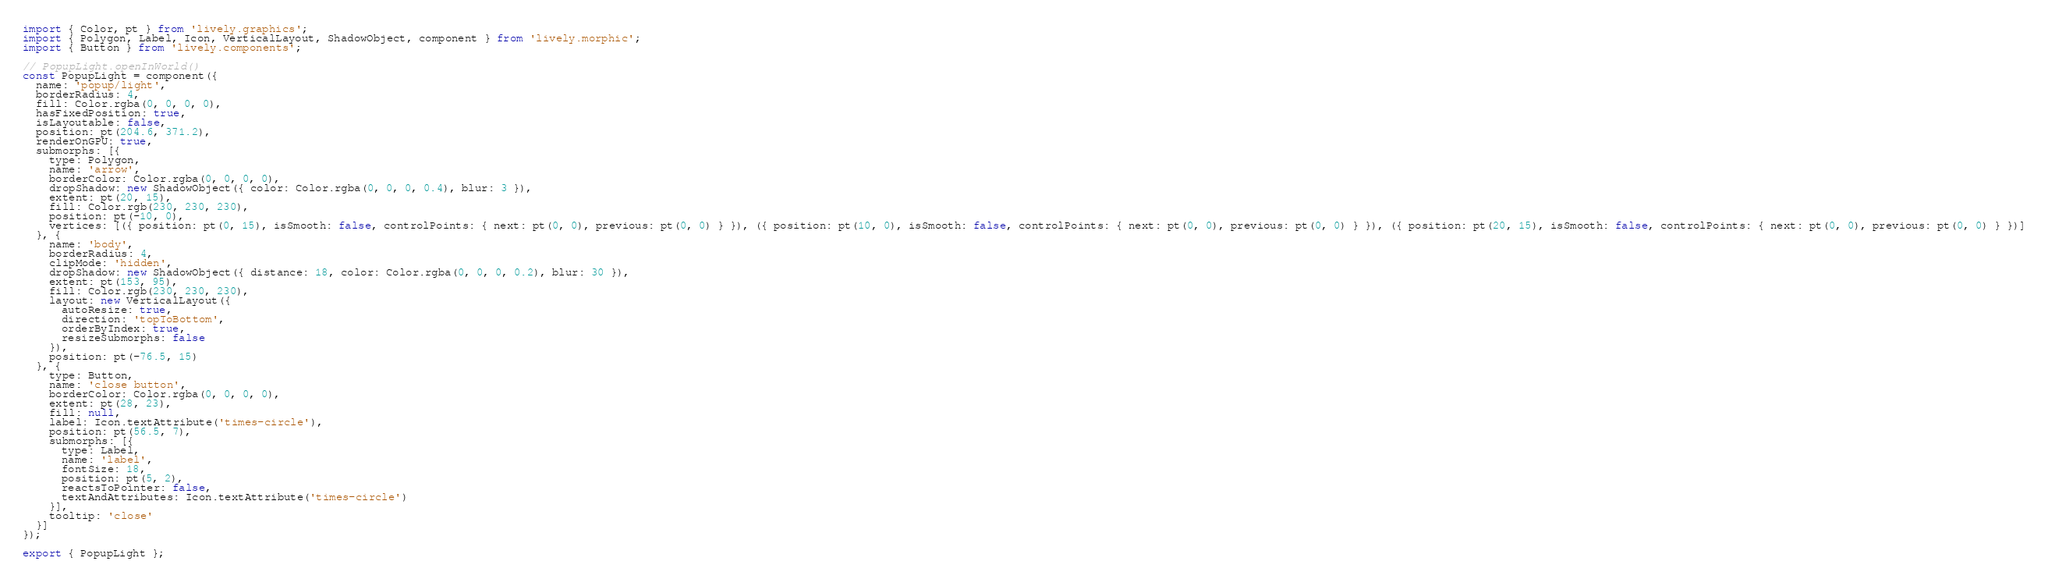<code> <loc_0><loc_0><loc_500><loc_500><_JavaScript_>import { Color, pt } from 'lively.graphics';
import { Polygon, Label, Icon, VerticalLayout, ShadowObject, component } from 'lively.morphic';
import { Button } from 'lively.components';

// PopupLight.openInWorld()
const PopupLight = component({
  name: 'popup/light',
  borderRadius: 4,
  fill: Color.rgba(0, 0, 0, 0),
  hasFixedPosition: true,
  isLayoutable: false,
  position: pt(204.6, 371.2),
  renderOnGPU: true,
  submorphs: [{
    type: Polygon,
    name: 'arrow',
    borderColor: Color.rgba(0, 0, 0, 0),
    dropShadow: new ShadowObject({ color: Color.rgba(0, 0, 0, 0.4), blur: 3 }),
    extent: pt(20, 15),
    fill: Color.rgb(230, 230, 230),
    position: pt(-10, 0),
    vertices: [({ position: pt(0, 15), isSmooth: false, controlPoints: { next: pt(0, 0), previous: pt(0, 0) } }), ({ position: pt(10, 0), isSmooth: false, controlPoints: { next: pt(0, 0), previous: pt(0, 0) } }), ({ position: pt(20, 15), isSmooth: false, controlPoints: { next: pt(0, 0), previous: pt(0, 0) } })]
  }, {
    name: 'body',
    borderRadius: 4,
    clipMode: 'hidden',
    dropShadow: new ShadowObject({ distance: 18, color: Color.rgba(0, 0, 0, 0.2), blur: 30 }),
    extent: pt(153, 95),
    fill: Color.rgb(230, 230, 230),
    layout: new VerticalLayout({
      autoResize: true,
      direction: 'topToBottom',
      orderByIndex: true,
      resizeSubmorphs: false
    }),
    position: pt(-76.5, 15)
  }, {
    type: Button,
    name: 'close button',
    borderColor: Color.rgba(0, 0, 0, 0),
    extent: pt(28, 23),
    fill: null,
    label: Icon.textAttribute('times-circle'),
    position: pt(56.5, 7),
    submorphs: [{
      type: Label,
      name: 'label',
      fontSize: 18,
      position: pt(5, 2),
      reactsToPointer: false,
      textAndAttributes: Icon.textAttribute('times-circle')
    }],
    tooltip: 'close'
  }]
});

export { PopupLight };
</code> 